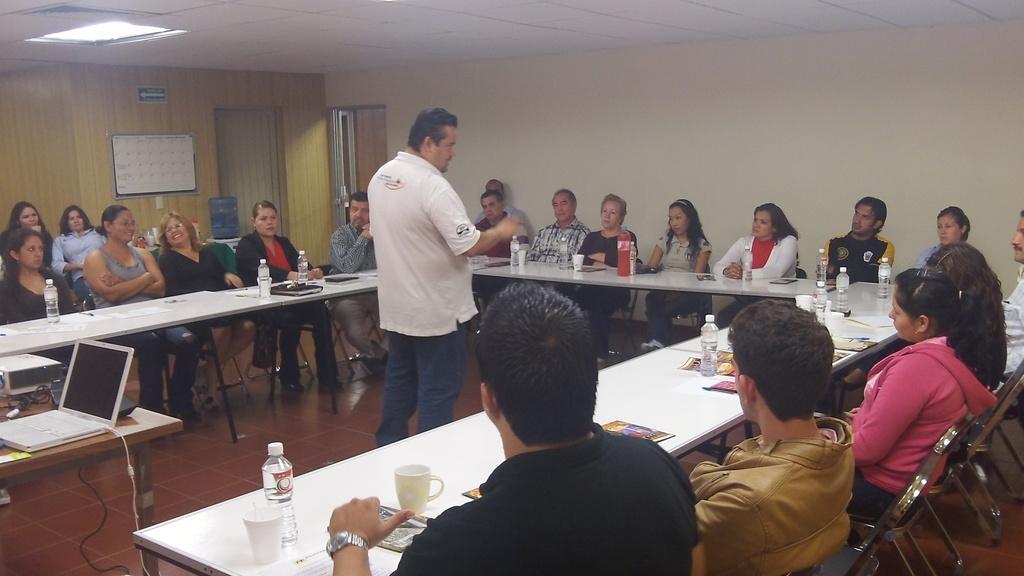Describe this image in one or two sentences. This room consists of tables and people sitting around the tables on chairs. On tables there are water bottles, cups ,papers ,books ,files. The person is standing in the middle. There is a door on the middle. There is a whiteboard on the left side. In the bottom left corner there is laptop ,wire. 